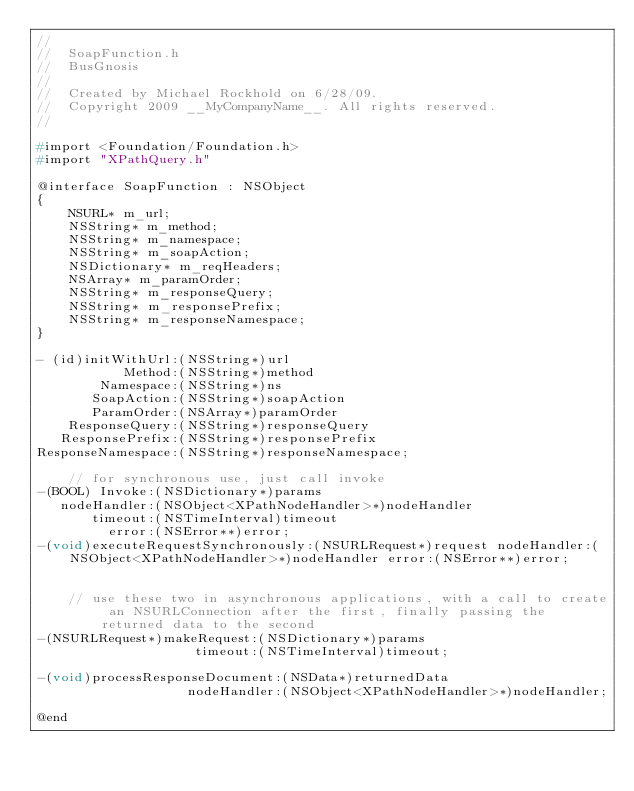<code> <loc_0><loc_0><loc_500><loc_500><_C_>//
//  SoapFunction.h
//  BusGnosis
//
//  Created by Michael Rockhold on 6/28/09.
//  Copyright 2009 __MyCompanyName__. All rights reserved.
//

#import <Foundation/Foundation.h>
#import "XPathQuery.h"

@interface SoapFunction : NSObject
{
	NSURL* m_url;
	NSString* m_method;
	NSString* m_namespace;
	NSString* m_soapAction;
	NSDictionary* m_reqHeaders;
	NSArray* m_paramOrder;
	NSString* m_responseQuery;
	NSString* m_responsePrefix;
	NSString* m_responseNamespace;
}

- (id)initWithUrl:(NSString*)url
		   Method:(NSString*)method
		Namespace:(NSString*)ns
	   SoapAction:(NSString*)soapAction
	   ParamOrder:(NSArray*)paramOrder
	ResponseQuery:(NSString*)responseQuery
   ResponsePrefix:(NSString*)responsePrefix
ResponseNamespace:(NSString*)responseNamespace;

	// for synchronous use, just call invoke
-(BOOL) Invoke:(NSDictionary*)params 
   nodeHandler:(NSObject<XPathNodeHandler>*)nodeHandler 
	   timeout:(NSTimeInterval)timeout 
		 error:(NSError**)error;
-(void)executeRequestSynchronously:(NSURLRequest*)request nodeHandler:(NSObject<XPathNodeHandler>*)nodeHandler error:(NSError**)error;


	// use these two in asynchronous applications, with a call to create an NSURLConnection after the first, finally passing the returned data to the second
-(NSURLRequest*)makeRequest:(NSDictionary*)params 
					timeout:(NSTimeInterval)timeout;

-(void)processResponseDocument:(NSData*)returnedData 
				   nodeHandler:(NSObject<XPathNodeHandler>*)nodeHandler;

@end
</code> 